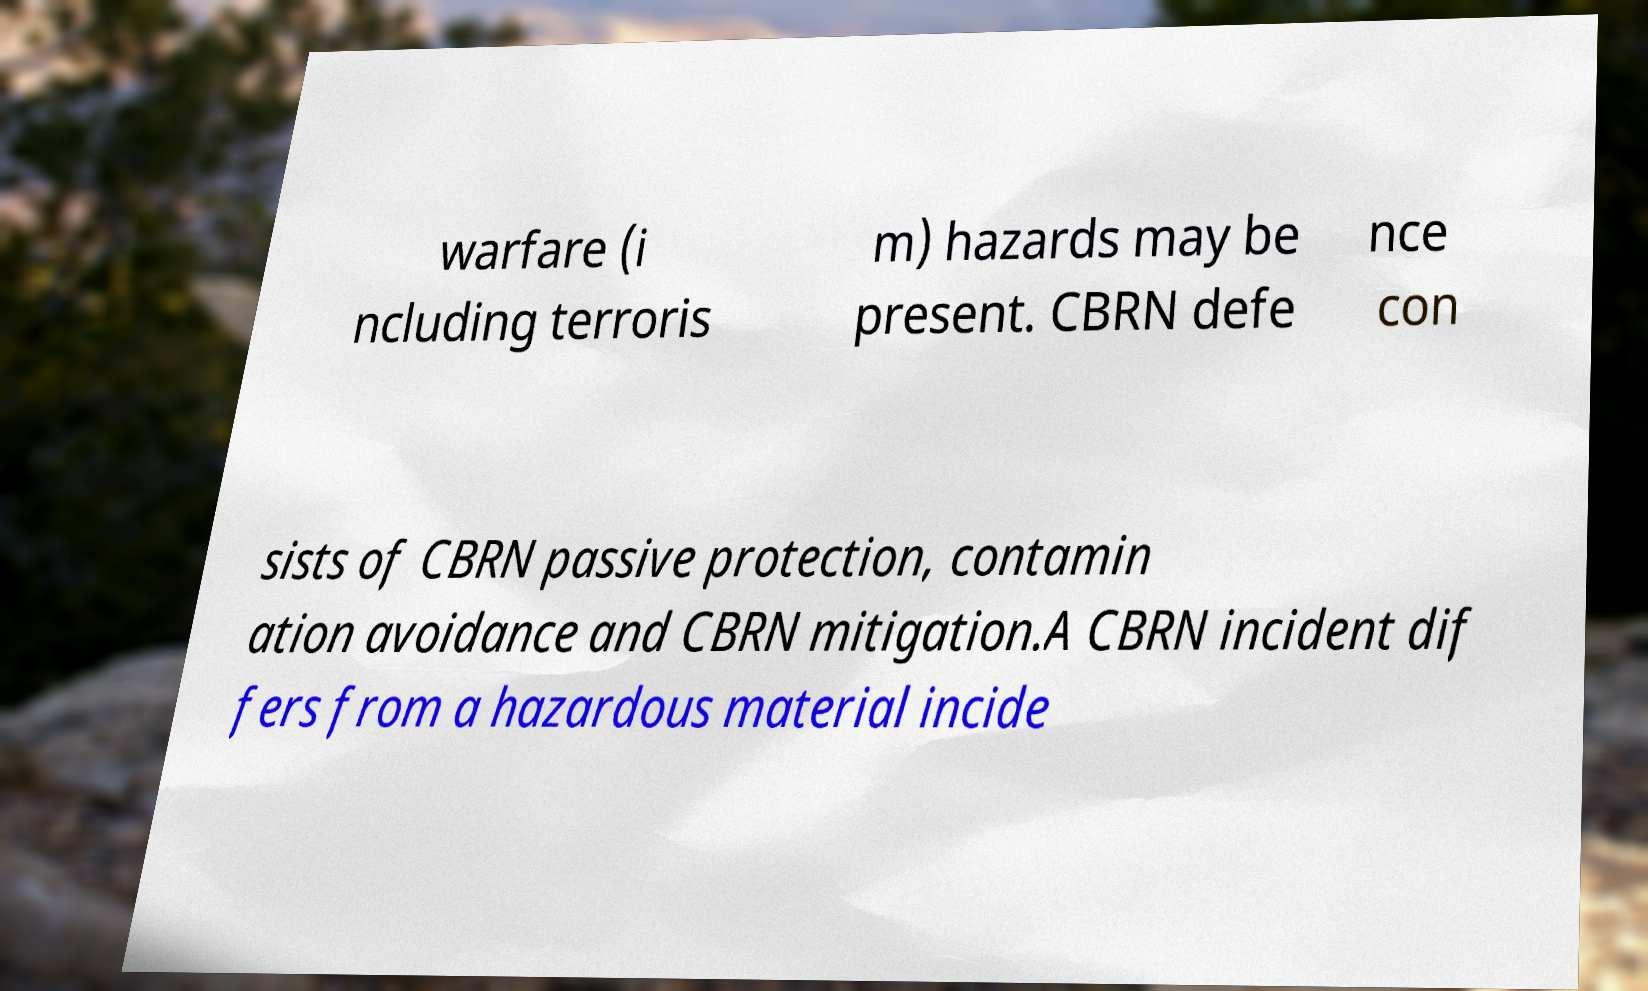Can you accurately transcribe the text from the provided image for me? warfare (i ncluding terroris m) hazards may be present. CBRN defe nce con sists of CBRN passive protection, contamin ation avoidance and CBRN mitigation.A CBRN incident dif fers from a hazardous material incide 